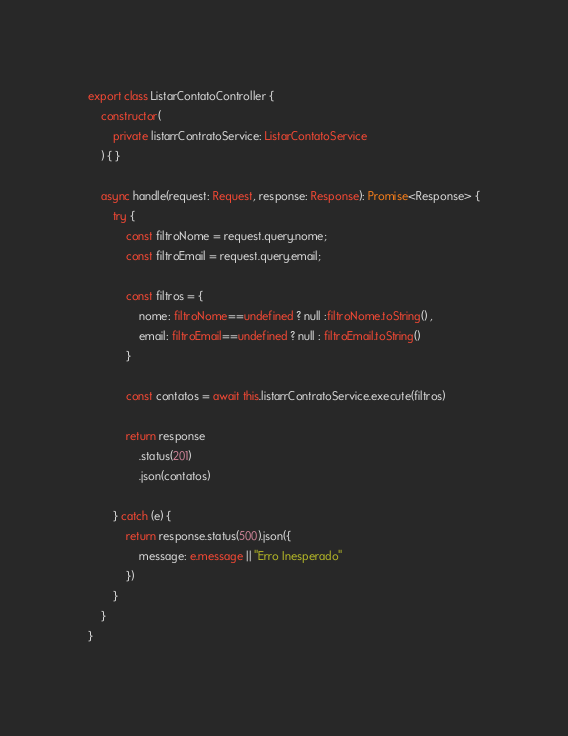<code> <loc_0><loc_0><loc_500><loc_500><_TypeScript_>export class ListarContatoController {
    constructor(
        private listarrContratoService: ListarContatoService
    ) { }

    async handle(request: Request, response: Response): Promise<Response> {
        try {
            const filtroNome = request.query.nome;
            const filtroEmail = request.query.email;

            const filtros = {
                nome: filtroNome==undefined ? null :filtroNome.toString() ,
                email: filtroEmail==undefined ? null : filtroEmail.toString()
            }

            const contatos = await this.listarrContratoService.execute(filtros)

            return response
                .status(201)
                .json(contatos)

        } catch (e) {
            return response.status(500).json({
                message: e.message || "Erro Inesperado"
            })
        }
    }
}</code> 